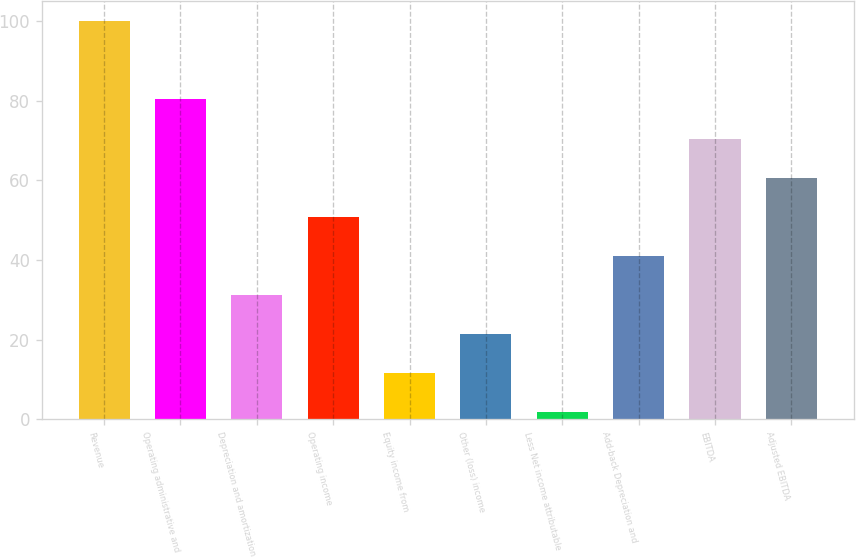Convert chart. <chart><loc_0><loc_0><loc_500><loc_500><bar_chart><fcel>Revenue<fcel>Operating administrative and<fcel>Depreciation and amortization<fcel>Operating income<fcel>Equity income from<fcel>Other (loss) income<fcel>Less Net income attributable<fcel>Add-back Depreciation and<fcel>EBITDA<fcel>Adjusted EBITDA<nl><fcel>100<fcel>80.34<fcel>31.19<fcel>50.85<fcel>11.53<fcel>21.36<fcel>1.7<fcel>41.02<fcel>70.51<fcel>60.68<nl></chart> 